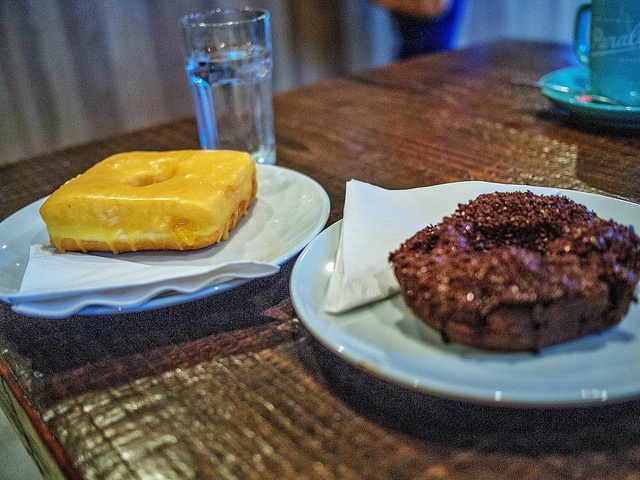Describe the objects in this image and their specific colors. I can see dining table in black, maroon, and gray tones, donut in black, maroon, and brown tones, donut in black, orange, olive, and tan tones, cup in black and gray tones, and cup in black, teal, and gray tones in this image. 